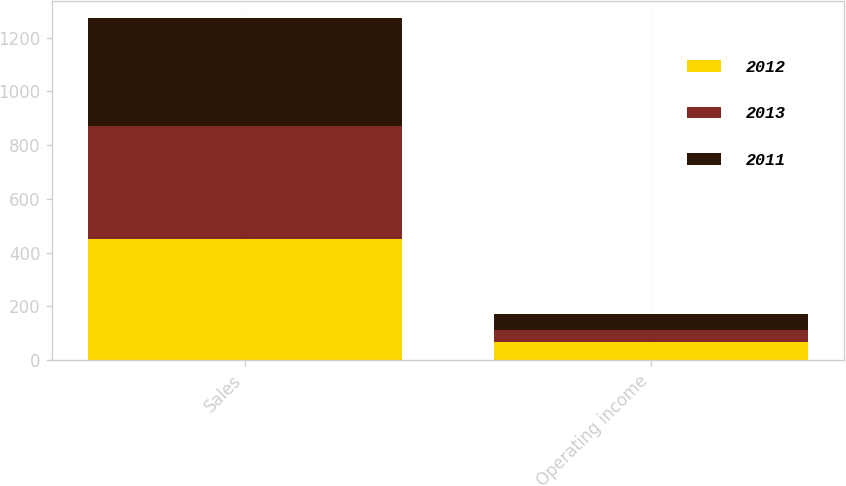Convert chart to OTSL. <chart><loc_0><loc_0><loc_500><loc_500><stacked_bar_chart><ecel><fcel>Sales<fcel>Operating income<nl><fcel>2012<fcel>451.1<fcel>65.5<nl><fcel>2013<fcel>420.1<fcel>44.6<nl><fcel>2011<fcel>400.6<fcel>62.8<nl></chart> 